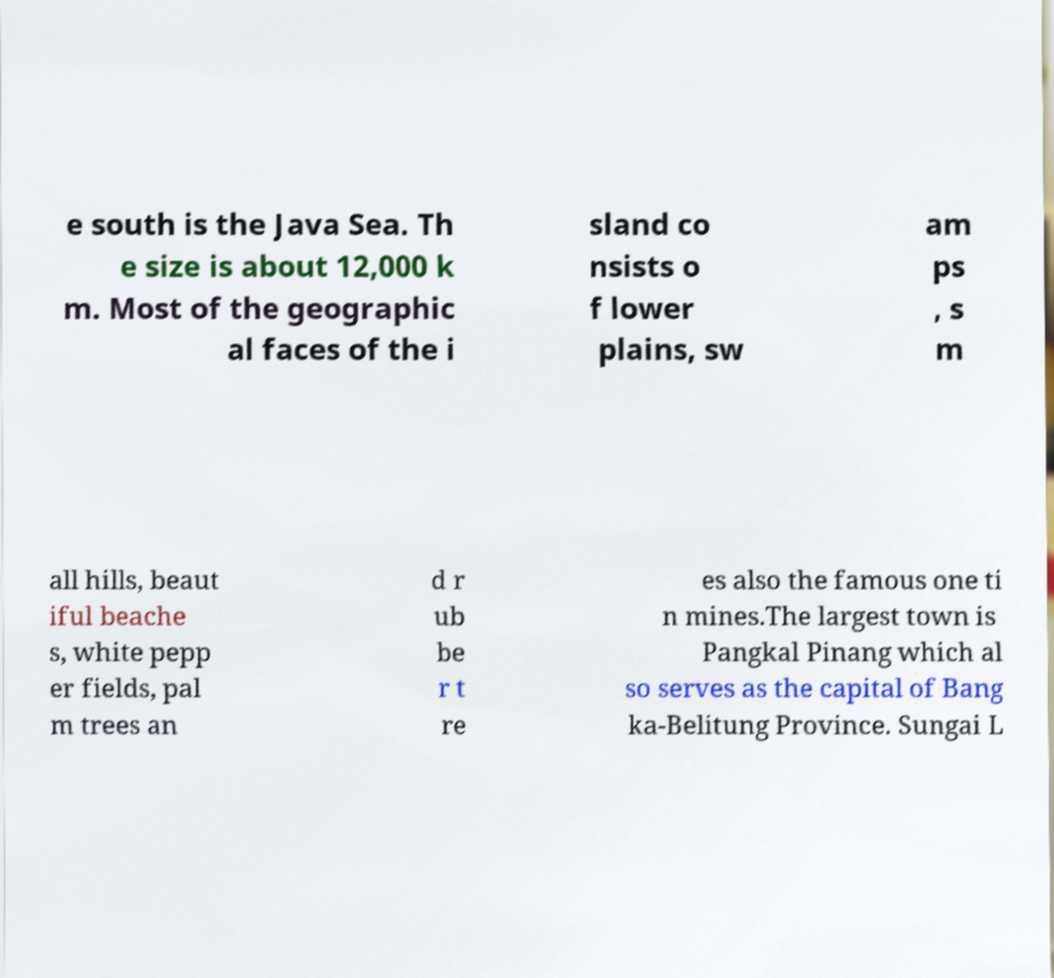There's text embedded in this image that I need extracted. Can you transcribe it verbatim? e south is the Java Sea. Th e size is about 12,000 k m. Most of the geographic al faces of the i sland co nsists o f lower plains, sw am ps , s m all hills, beaut iful beache s, white pepp er fields, pal m trees an d r ub be r t re es also the famous one ti n mines.The largest town is Pangkal Pinang which al so serves as the capital of Bang ka-Belitung Province. Sungai L 